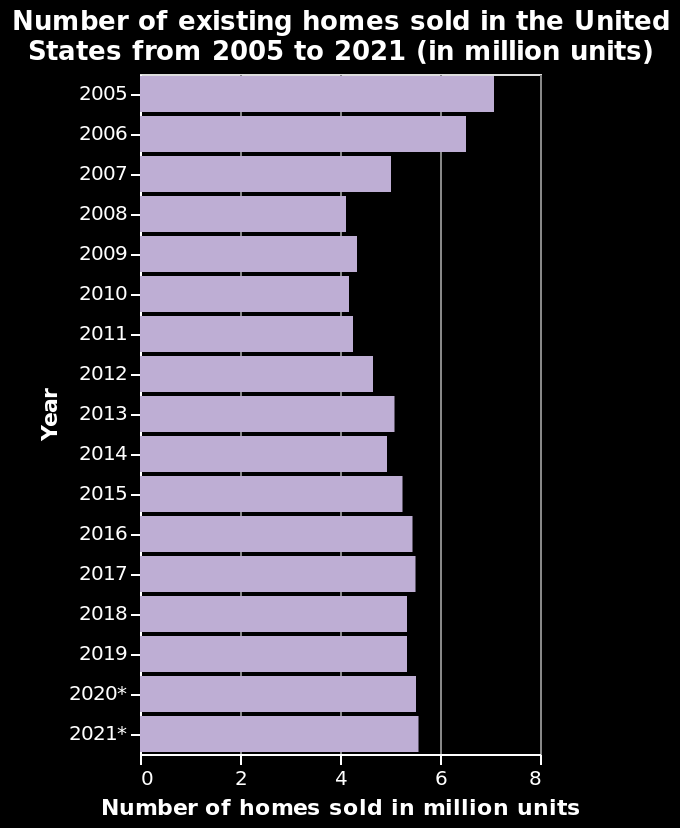<image>
What is the main subject of the figure? The main subject of the figure is the sales of existing homes from 2007 to 2019. What is the range of the y-axis scale? The range of the y-axis scale is from 2005 to 2021. What does the bar chart represent? The bar chart represents the number of existing homes sold in the United States from 2005 to 2021, measured in million units. 